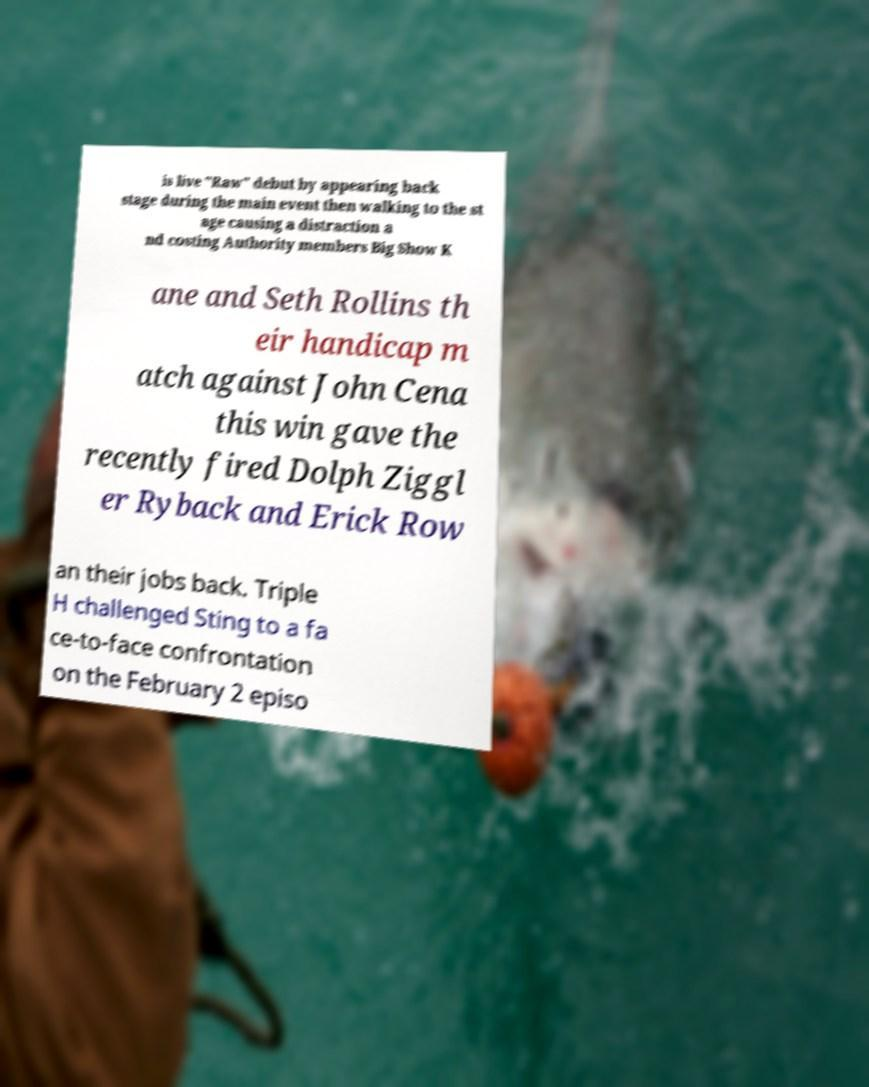Please identify and transcribe the text found in this image. is live "Raw" debut by appearing back stage during the main event then walking to the st age causing a distraction a nd costing Authority members Big Show K ane and Seth Rollins th eir handicap m atch against John Cena this win gave the recently fired Dolph Ziggl er Ryback and Erick Row an their jobs back. Triple H challenged Sting to a fa ce-to-face confrontation on the February 2 episo 